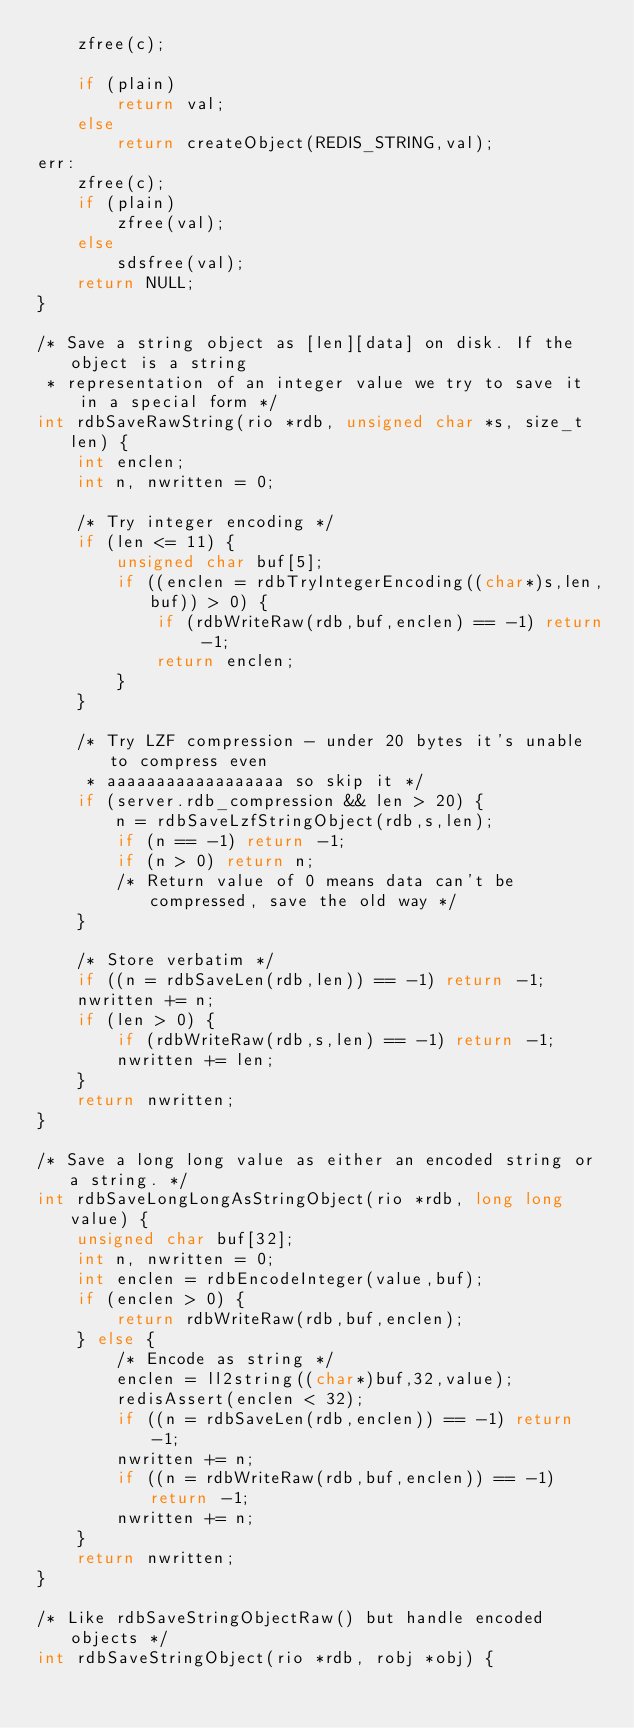Convert code to text. <code><loc_0><loc_0><loc_500><loc_500><_C_>    zfree(c);

    if (plain)
        return val;
    else
        return createObject(REDIS_STRING,val);
err:
    zfree(c);
    if (plain)
        zfree(val);
    else
        sdsfree(val);
    return NULL;
}

/* Save a string object as [len][data] on disk. If the object is a string
 * representation of an integer value we try to save it in a special form */
int rdbSaveRawString(rio *rdb, unsigned char *s, size_t len) {
    int enclen;
    int n, nwritten = 0;

    /* Try integer encoding */
    if (len <= 11) {
        unsigned char buf[5];
        if ((enclen = rdbTryIntegerEncoding((char*)s,len,buf)) > 0) {
            if (rdbWriteRaw(rdb,buf,enclen) == -1) return -1;
            return enclen;
        }
    }

    /* Try LZF compression - under 20 bytes it's unable to compress even
     * aaaaaaaaaaaaaaaaaa so skip it */
    if (server.rdb_compression && len > 20) {
        n = rdbSaveLzfStringObject(rdb,s,len);
        if (n == -1) return -1;
        if (n > 0) return n;
        /* Return value of 0 means data can't be compressed, save the old way */
    }

    /* Store verbatim */
    if ((n = rdbSaveLen(rdb,len)) == -1) return -1;
    nwritten += n;
    if (len > 0) {
        if (rdbWriteRaw(rdb,s,len) == -1) return -1;
        nwritten += len;
    }
    return nwritten;
}

/* Save a long long value as either an encoded string or a string. */
int rdbSaveLongLongAsStringObject(rio *rdb, long long value) {
    unsigned char buf[32];
    int n, nwritten = 0;
    int enclen = rdbEncodeInteger(value,buf);
    if (enclen > 0) {
        return rdbWriteRaw(rdb,buf,enclen);
    } else {
        /* Encode as string */
        enclen = ll2string((char*)buf,32,value);
        redisAssert(enclen < 32);
        if ((n = rdbSaveLen(rdb,enclen)) == -1) return -1;
        nwritten += n;
        if ((n = rdbWriteRaw(rdb,buf,enclen)) == -1) return -1;
        nwritten += n;
    }
    return nwritten;
}

/* Like rdbSaveStringObjectRaw() but handle encoded objects */
int rdbSaveStringObject(rio *rdb, robj *obj) {</code> 